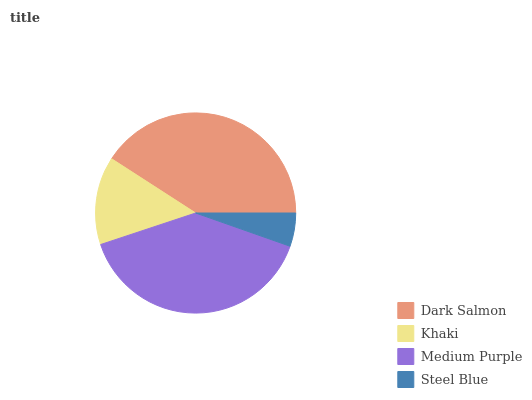Is Steel Blue the minimum?
Answer yes or no. Yes. Is Dark Salmon the maximum?
Answer yes or no. Yes. Is Khaki the minimum?
Answer yes or no. No. Is Khaki the maximum?
Answer yes or no. No. Is Dark Salmon greater than Khaki?
Answer yes or no. Yes. Is Khaki less than Dark Salmon?
Answer yes or no. Yes. Is Khaki greater than Dark Salmon?
Answer yes or no. No. Is Dark Salmon less than Khaki?
Answer yes or no. No. Is Medium Purple the high median?
Answer yes or no. Yes. Is Khaki the low median?
Answer yes or no. Yes. Is Dark Salmon the high median?
Answer yes or no. No. Is Steel Blue the low median?
Answer yes or no. No. 